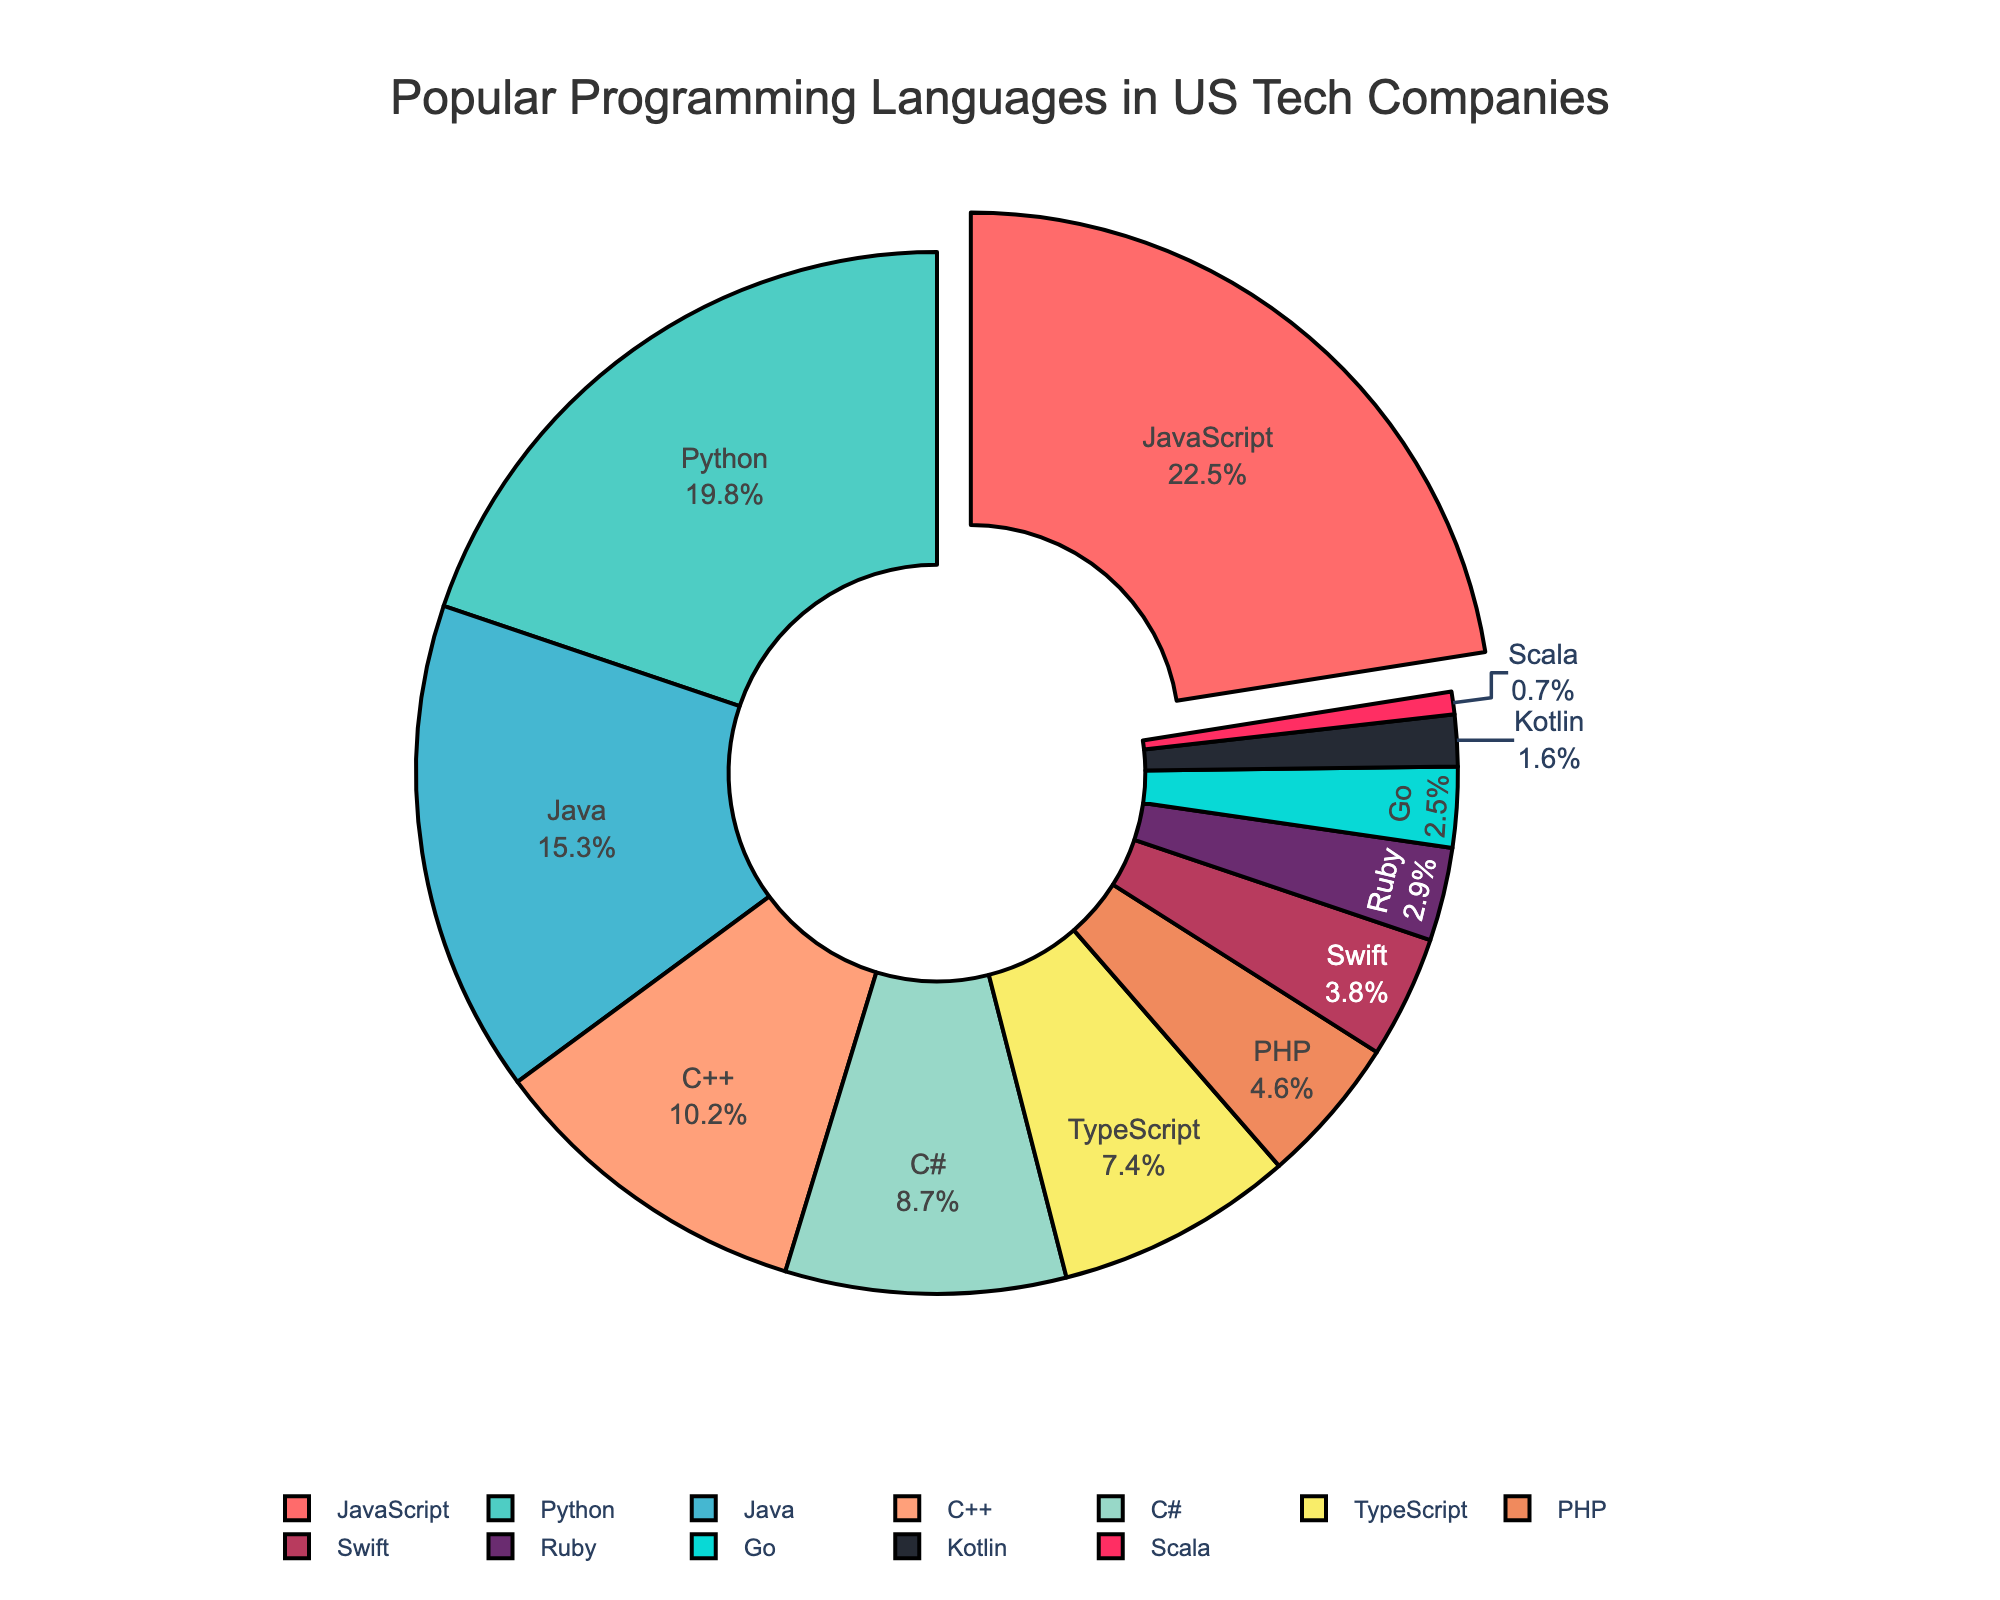What is the most popular programming language in US tech companies? The slice representing JavaScript is pulled out from the pie chart, indicating it is the most popular programming language. Additionally, JavaScript has the highest percentage in the legend.
Answer: JavaScript Which programming language is used less frequently, Swift or Go? The percentage for Swift (3.8%) is higher than that for Go (2.5%), as shown by the larger area of the Swift slice compared to the Go slice.
Answer: Go What is the combined percentage of JavaScript and Python usage in US tech companies? JavaScript has a percentage of 22.5%, and Python has 19.8%. Adding these together, we get 22.5% + 19.8% = 42.3%.
Answer: 42.3% How does the usage of C++ compare to C#? C++ has a usage percentage of 10.2%, whereas C# has a percentage of 8.7%. Since 10.2% > 8.7%, C++ is used more frequently than C#.
Answer: C++ What is the least popular programming language among the given data? The slice for Scala has the smallest area among all slices, and its percentage in the legend is 0.7%, making it the least popular programming language.
Answer: Scala Which language has a larger share, PHP or Ruby? PHP has a percentage of 4.6%, while Ruby has 2.9%. Since 4.6% > 2.9%, PHP has a larger share than Ruby.
Answer: PHP What is the difference in usage percentage between TypeScript and Kotlin? TypeScript is at 7.4% and Kotlin is at 1.6%. The difference is 7.4% - 1.6% = 5.8%.
Answer: 5.8% Which segment of the pie chart has the darkest color and what language does it represent? The slice representing Kotlin has the darkest color and can be identified by its small size and deep-colored segment.
Answer: Kotlin Out of C++ and TypeScript, which programming language has a higher usage percentage? C++ has a higher usage percentage at 10.2% compared to TypeScript's 7.4%.
Answer: C++ What is the average percentage of Java, PHP, and Ruby usage in US tech companies? Adding the percentages of Java (15.3%), PHP (4.6%), and Ruby (2.9%) gives 15.3% + 4.6% + 2.9% = 22.8%. The average is then 22.8% / 3 = 7.6%.
Answer: 7.6% 